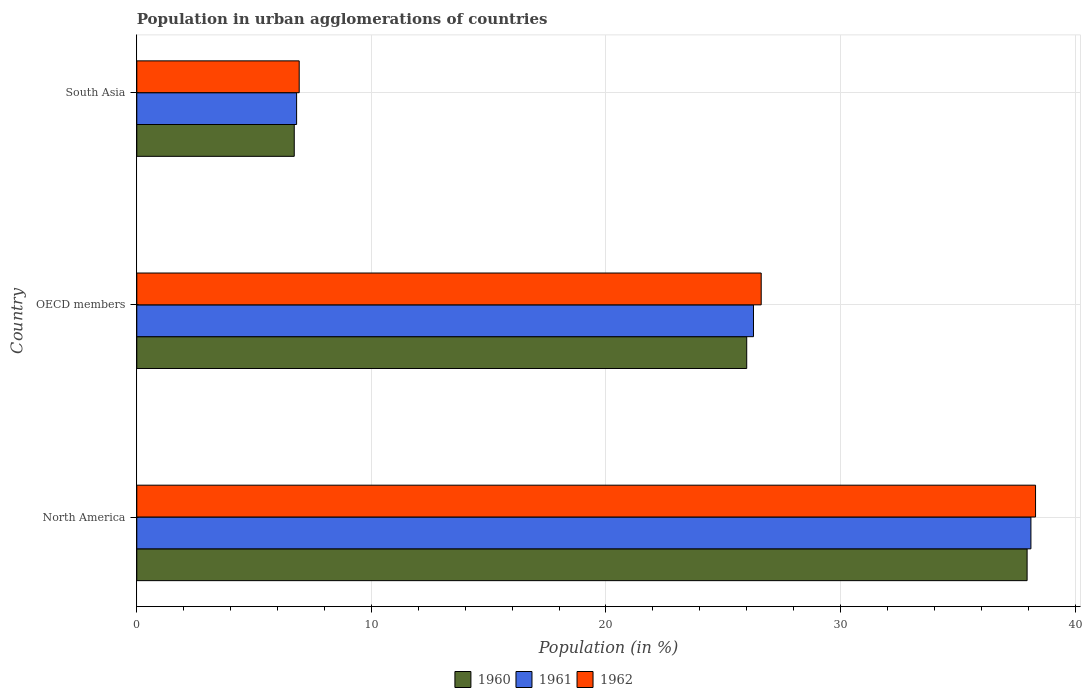How many groups of bars are there?
Offer a very short reply. 3. How many bars are there on the 1st tick from the bottom?
Provide a short and direct response. 3. What is the label of the 2nd group of bars from the top?
Keep it short and to the point. OECD members. In how many cases, is the number of bars for a given country not equal to the number of legend labels?
Make the answer very short. 0. What is the percentage of population in urban agglomerations in 1962 in OECD members?
Your answer should be compact. 26.62. Across all countries, what is the maximum percentage of population in urban agglomerations in 1960?
Give a very brief answer. 37.95. Across all countries, what is the minimum percentage of population in urban agglomerations in 1960?
Give a very brief answer. 6.71. What is the total percentage of population in urban agglomerations in 1960 in the graph?
Keep it short and to the point. 70.67. What is the difference between the percentage of population in urban agglomerations in 1960 in OECD members and that in South Asia?
Offer a terse response. 19.29. What is the difference between the percentage of population in urban agglomerations in 1960 in North America and the percentage of population in urban agglomerations in 1962 in South Asia?
Your answer should be very brief. 31.03. What is the average percentage of population in urban agglomerations in 1961 per country?
Provide a succinct answer. 23.74. What is the difference between the percentage of population in urban agglomerations in 1961 and percentage of population in urban agglomerations in 1962 in OECD members?
Keep it short and to the point. -0.33. In how many countries, is the percentage of population in urban agglomerations in 1961 greater than 14 %?
Keep it short and to the point. 2. What is the ratio of the percentage of population in urban agglomerations in 1960 in OECD members to that in South Asia?
Give a very brief answer. 3.87. Is the percentage of population in urban agglomerations in 1962 in OECD members less than that in South Asia?
Offer a terse response. No. What is the difference between the highest and the second highest percentage of population in urban agglomerations in 1961?
Give a very brief answer. 11.83. What is the difference between the highest and the lowest percentage of population in urban agglomerations in 1960?
Offer a terse response. 31.24. What does the 2nd bar from the top in North America represents?
Make the answer very short. 1961. What does the 1st bar from the bottom in South Asia represents?
Provide a succinct answer. 1960. Is it the case that in every country, the sum of the percentage of population in urban agglomerations in 1960 and percentage of population in urban agglomerations in 1962 is greater than the percentage of population in urban agglomerations in 1961?
Ensure brevity in your answer.  Yes. How many bars are there?
Offer a terse response. 9. What is the difference between two consecutive major ticks on the X-axis?
Your response must be concise. 10. How are the legend labels stacked?
Keep it short and to the point. Horizontal. What is the title of the graph?
Provide a succinct answer. Population in urban agglomerations of countries. What is the label or title of the Y-axis?
Your response must be concise. Country. What is the Population (in %) of 1960 in North America?
Ensure brevity in your answer.  37.95. What is the Population (in %) of 1961 in North America?
Offer a terse response. 38.12. What is the Population (in %) of 1962 in North America?
Your answer should be very brief. 38.31. What is the Population (in %) in 1960 in OECD members?
Your answer should be very brief. 26. What is the Population (in %) in 1961 in OECD members?
Offer a very short reply. 26.29. What is the Population (in %) of 1962 in OECD members?
Provide a succinct answer. 26.62. What is the Population (in %) in 1960 in South Asia?
Your response must be concise. 6.71. What is the Population (in %) of 1961 in South Asia?
Your answer should be very brief. 6.81. What is the Population (in %) of 1962 in South Asia?
Make the answer very short. 6.92. Across all countries, what is the maximum Population (in %) in 1960?
Give a very brief answer. 37.95. Across all countries, what is the maximum Population (in %) of 1961?
Offer a very short reply. 38.12. Across all countries, what is the maximum Population (in %) in 1962?
Your answer should be compact. 38.31. Across all countries, what is the minimum Population (in %) of 1960?
Your answer should be compact. 6.71. Across all countries, what is the minimum Population (in %) in 1961?
Provide a short and direct response. 6.81. Across all countries, what is the minimum Population (in %) in 1962?
Keep it short and to the point. 6.92. What is the total Population (in %) of 1960 in the graph?
Keep it short and to the point. 70.67. What is the total Population (in %) of 1961 in the graph?
Offer a terse response. 71.22. What is the total Population (in %) of 1962 in the graph?
Your response must be concise. 71.86. What is the difference between the Population (in %) of 1960 in North America and that in OECD members?
Provide a succinct answer. 11.95. What is the difference between the Population (in %) of 1961 in North America and that in OECD members?
Make the answer very short. 11.83. What is the difference between the Population (in %) of 1962 in North America and that in OECD members?
Offer a very short reply. 11.7. What is the difference between the Population (in %) of 1960 in North America and that in South Asia?
Keep it short and to the point. 31.24. What is the difference between the Population (in %) of 1961 in North America and that in South Asia?
Your answer should be very brief. 31.3. What is the difference between the Population (in %) of 1962 in North America and that in South Asia?
Provide a succinct answer. 31.39. What is the difference between the Population (in %) in 1960 in OECD members and that in South Asia?
Your response must be concise. 19.29. What is the difference between the Population (in %) in 1961 in OECD members and that in South Asia?
Make the answer very short. 19.48. What is the difference between the Population (in %) in 1962 in OECD members and that in South Asia?
Provide a short and direct response. 19.69. What is the difference between the Population (in %) of 1960 in North America and the Population (in %) of 1961 in OECD members?
Your response must be concise. 11.66. What is the difference between the Population (in %) of 1960 in North America and the Population (in %) of 1962 in OECD members?
Offer a very short reply. 11.34. What is the difference between the Population (in %) of 1961 in North America and the Population (in %) of 1962 in OECD members?
Your response must be concise. 11.5. What is the difference between the Population (in %) of 1960 in North America and the Population (in %) of 1961 in South Asia?
Ensure brevity in your answer.  31.14. What is the difference between the Population (in %) in 1960 in North America and the Population (in %) in 1962 in South Asia?
Give a very brief answer. 31.03. What is the difference between the Population (in %) of 1961 in North America and the Population (in %) of 1962 in South Asia?
Ensure brevity in your answer.  31.19. What is the difference between the Population (in %) in 1960 in OECD members and the Population (in %) in 1961 in South Asia?
Ensure brevity in your answer.  19.19. What is the difference between the Population (in %) of 1960 in OECD members and the Population (in %) of 1962 in South Asia?
Keep it short and to the point. 19.08. What is the difference between the Population (in %) of 1961 in OECD members and the Population (in %) of 1962 in South Asia?
Ensure brevity in your answer.  19.37. What is the average Population (in %) of 1960 per country?
Give a very brief answer. 23.56. What is the average Population (in %) in 1961 per country?
Your answer should be very brief. 23.74. What is the average Population (in %) of 1962 per country?
Make the answer very short. 23.95. What is the difference between the Population (in %) in 1960 and Population (in %) in 1961 in North America?
Ensure brevity in your answer.  -0.16. What is the difference between the Population (in %) of 1960 and Population (in %) of 1962 in North America?
Your answer should be compact. -0.36. What is the difference between the Population (in %) of 1961 and Population (in %) of 1962 in North America?
Your answer should be compact. -0.2. What is the difference between the Population (in %) in 1960 and Population (in %) in 1961 in OECD members?
Your response must be concise. -0.29. What is the difference between the Population (in %) of 1960 and Population (in %) of 1962 in OECD members?
Your answer should be compact. -0.62. What is the difference between the Population (in %) of 1961 and Population (in %) of 1962 in OECD members?
Offer a terse response. -0.33. What is the difference between the Population (in %) in 1960 and Population (in %) in 1961 in South Asia?
Your answer should be very brief. -0.1. What is the difference between the Population (in %) of 1960 and Population (in %) of 1962 in South Asia?
Keep it short and to the point. -0.21. What is the difference between the Population (in %) in 1961 and Population (in %) in 1962 in South Asia?
Keep it short and to the point. -0.11. What is the ratio of the Population (in %) in 1960 in North America to that in OECD members?
Keep it short and to the point. 1.46. What is the ratio of the Population (in %) of 1961 in North America to that in OECD members?
Your answer should be compact. 1.45. What is the ratio of the Population (in %) in 1962 in North America to that in OECD members?
Your answer should be compact. 1.44. What is the ratio of the Population (in %) of 1960 in North America to that in South Asia?
Offer a terse response. 5.65. What is the ratio of the Population (in %) in 1961 in North America to that in South Asia?
Your response must be concise. 5.59. What is the ratio of the Population (in %) of 1962 in North America to that in South Asia?
Ensure brevity in your answer.  5.53. What is the ratio of the Population (in %) of 1960 in OECD members to that in South Asia?
Give a very brief answer. 3.87. What is the ratio of the Population (in %) of 1961 in OECD members to that in South Asia?
Keep it short and to the point. 3.86. What is the ratio of the Population (in %) of 1962 in OECD members to that in South Asia?
Keep it short and to the point. 3.84. What is the difference between the highest and the second highest Population (in %) of 1960?
Provide a short and direct response. 11.95. What is the difference between the highest and the second highest Population (in %) of 1961?
Provide a succinct answer. 11.83. What is the difference between the highest and the second highest Population (in %) of 1962?
Provide a short and direct response. 11.7. What is the difference between the highest and the lowest Population (in %) of 1960?
Provide a succinct answer. 31.24. What is the difference between the highest and the lowest Population (in %) of 1961?
Your answer should be very brief. 31.3. What is the difference between the highest and the lowest Population (in %) in 1962?
Offer a terse response. 31.39. 